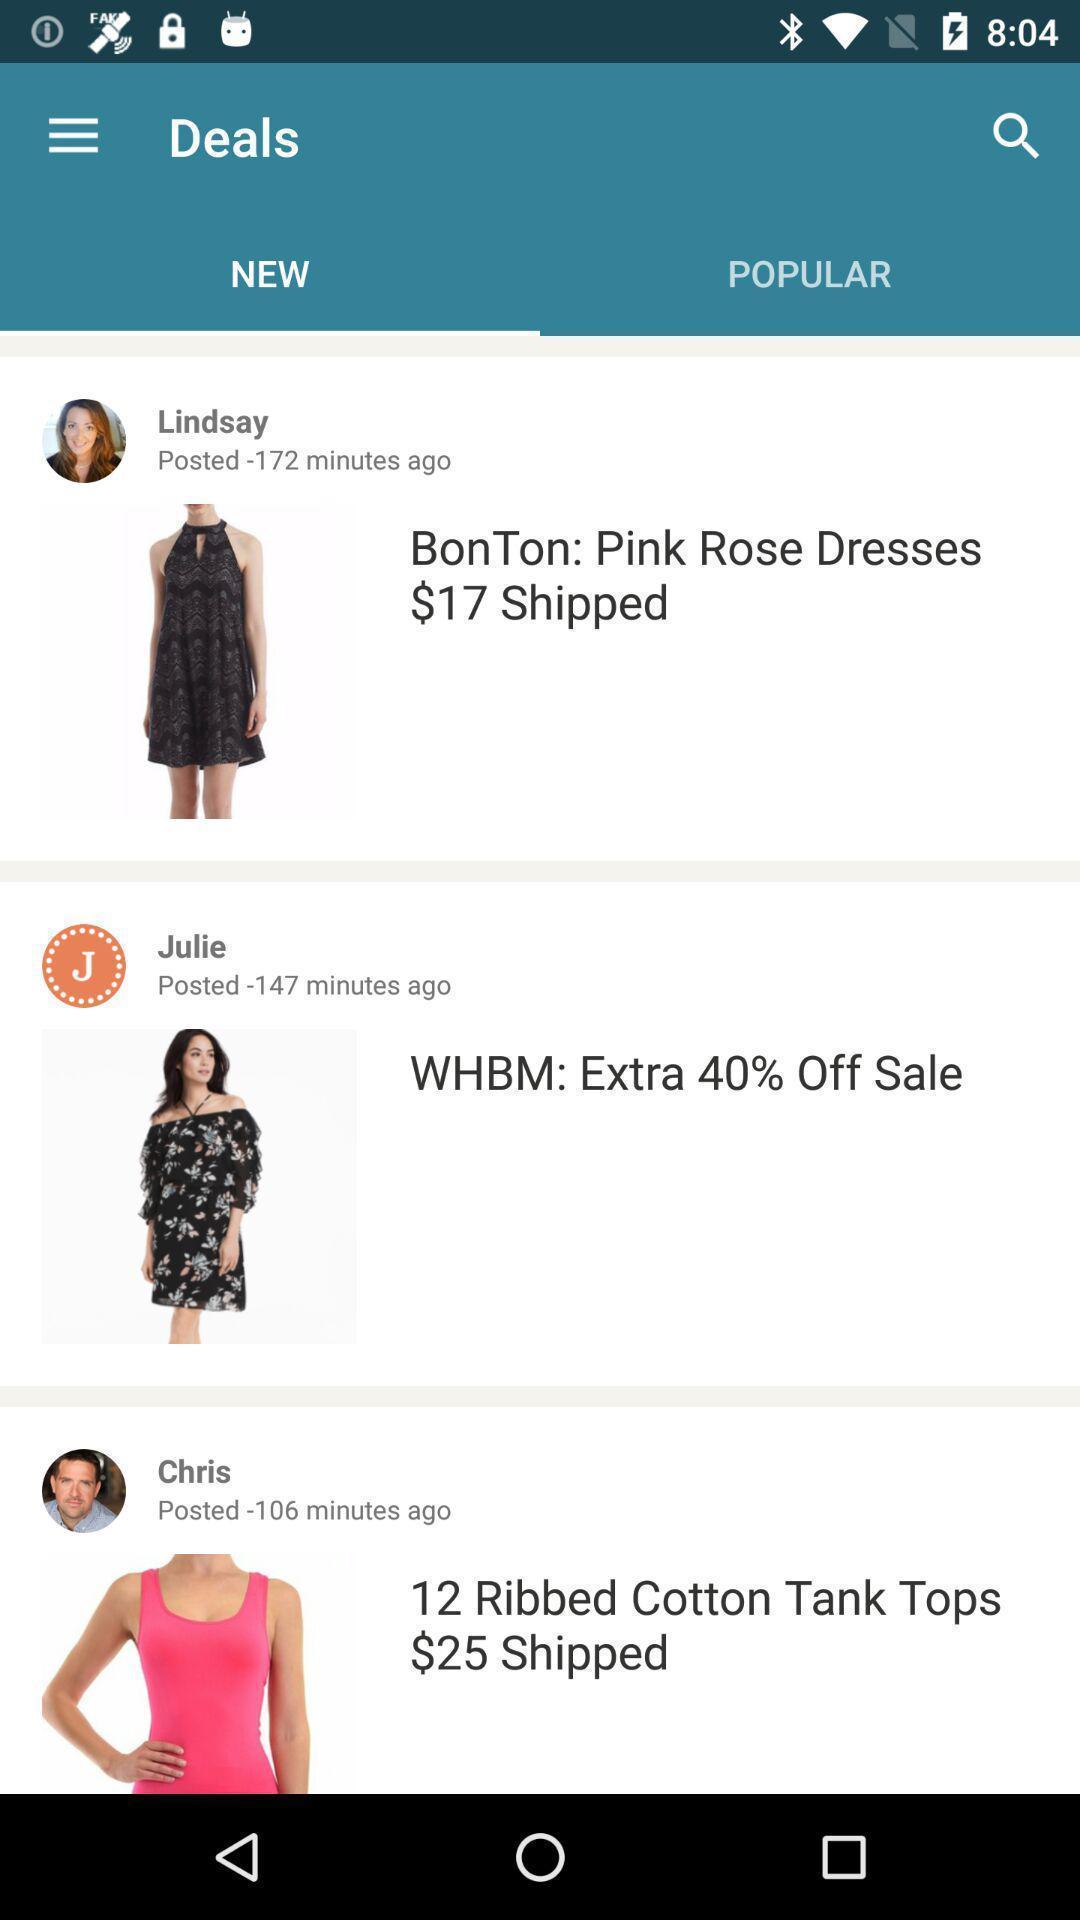Describe the key features of this screenshot. Page of a shopping application. 